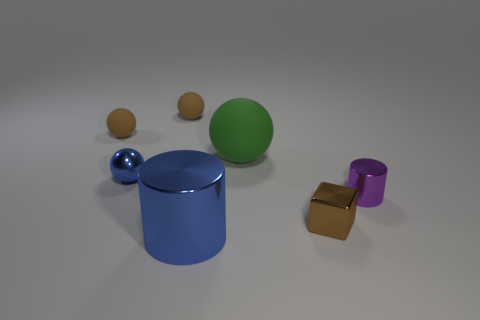Subtract 1 spheres. How many spheres are left? 3 Add 2 brown objects. How many objects exist? 9 Subtract all blocks. How many objects are left? 6 Subtract 1 purple cylinders. How many objects are left? 6 Subtract all blue things. Subtract all big green objects. How many objects are left? 4 Add 4 blue metallic balls. How many blue metallic balls are left? 5 Add 4 large yellow metallic spheres. How many large yellow metallic spheres exist? 4 